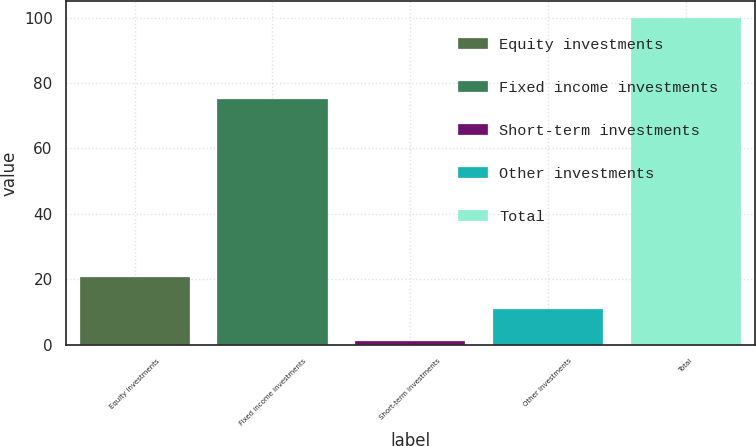<chart> <loc_0><loc_0><loc_500><loc_500><bar_chart><fcel>Equity investments<fcel>Fixed income investments<fcel>Short-term investments<fcel>Other investments<fcel>Total<nl><fcel>20.8<fcel>75<fcel>1<fcel>10.9<fcel>100<nl></chart> 